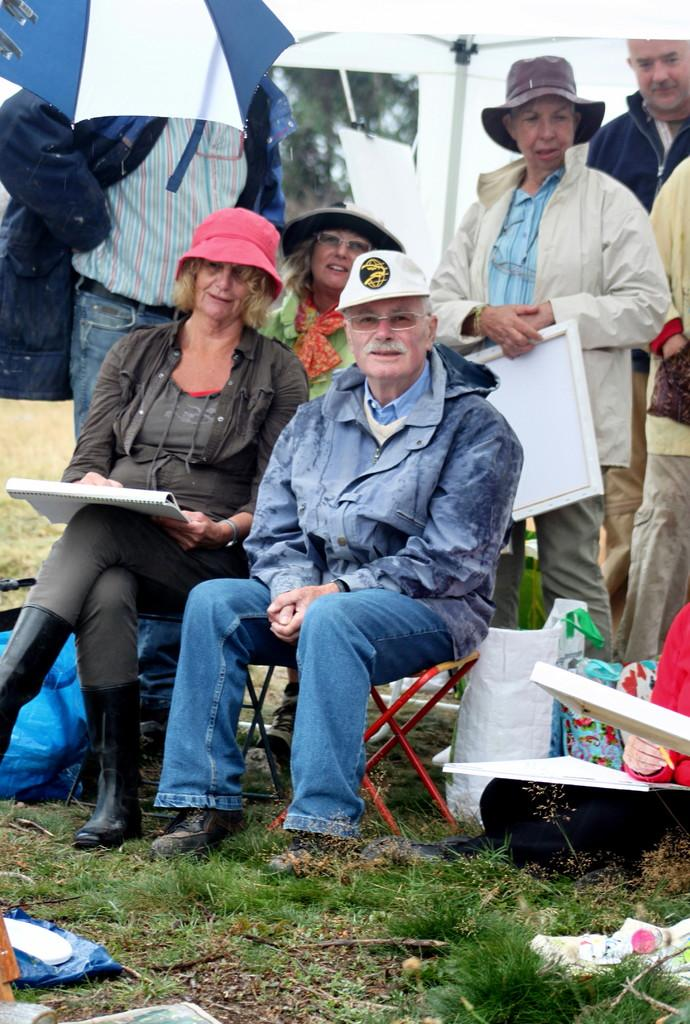How many people are visible in the image? There are two persons sitting in the image, and additional persons are standing behind them. What are the sitting persons doing? The information provided does not specify what the sitting persons are doing. Can you describe the position of the standing persons? The standing persons are positioned behind the sitting persons. What type of letters are being delivered by the vessel in the image? There is no vessel or letters present in the image. What kind of bun is being held by the person in the image? There is no bun present in the image. 